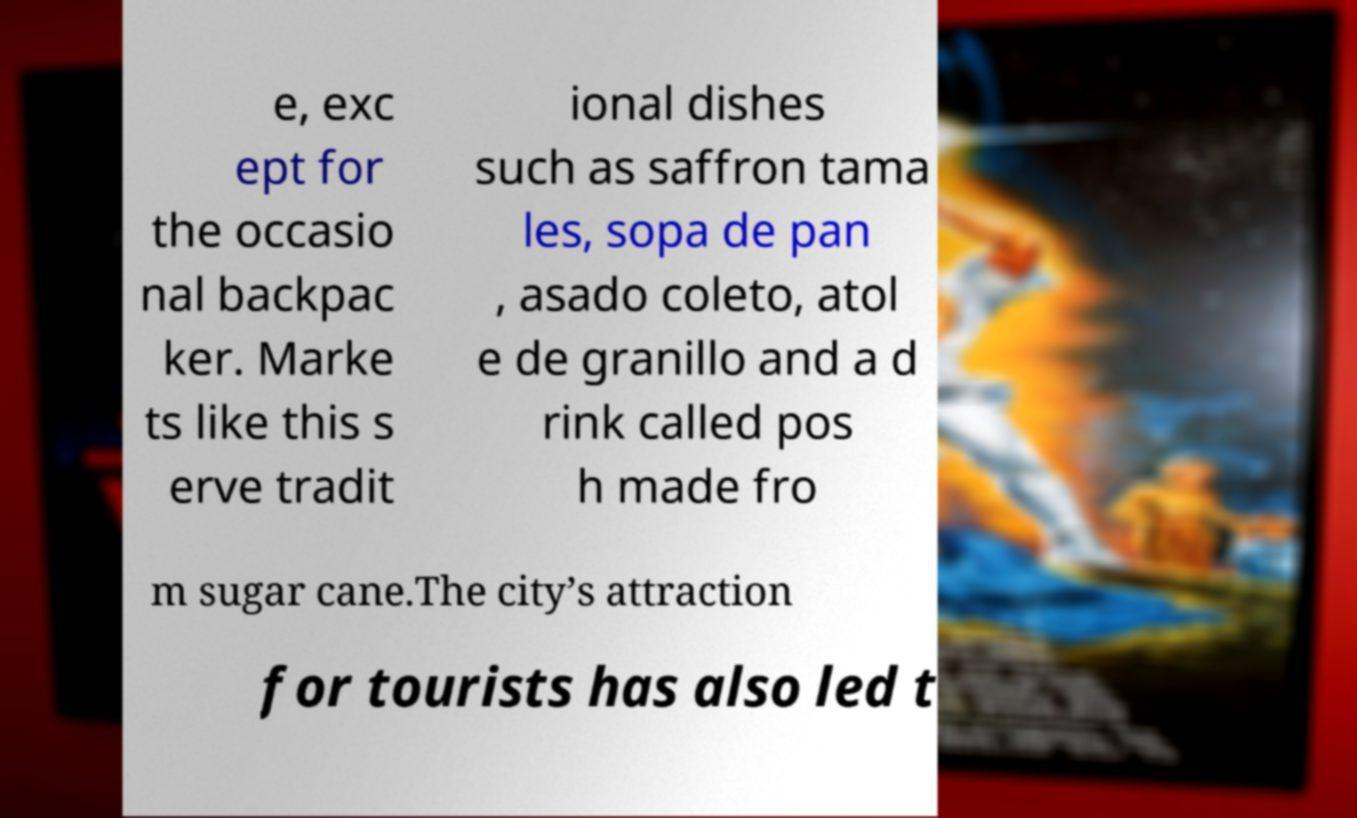For documentation purposes, I need the text within this image transcribed. Could you provide that? e, exc ept for the occasio nal backpac ker. Marke ts like this s erve tradit ional dishes such as saffron tama les, sopa de pan , asado coleto, atol e de granillo and a d rink called pos h made fro m sugar cane.The city’s attraction for tourists has also led t 